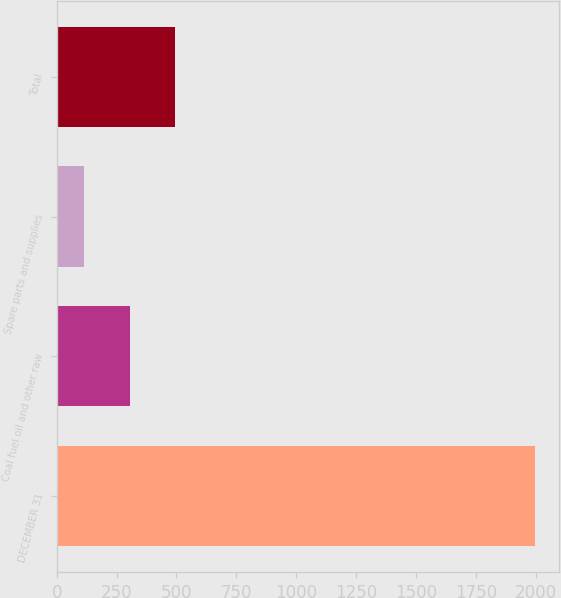Convert chart to OTSL. <chart><loc_0><loc_0><loc_500><loc_500><bar_chart><fcel>DECEMBER 31<fcel>Coal fuel oil and other raw<fcel>Spare parts and supplies<fcel>Total<nl><fcel>1999<fcel>304.3<fcel>116<fcel>492.6<nl></chart> 